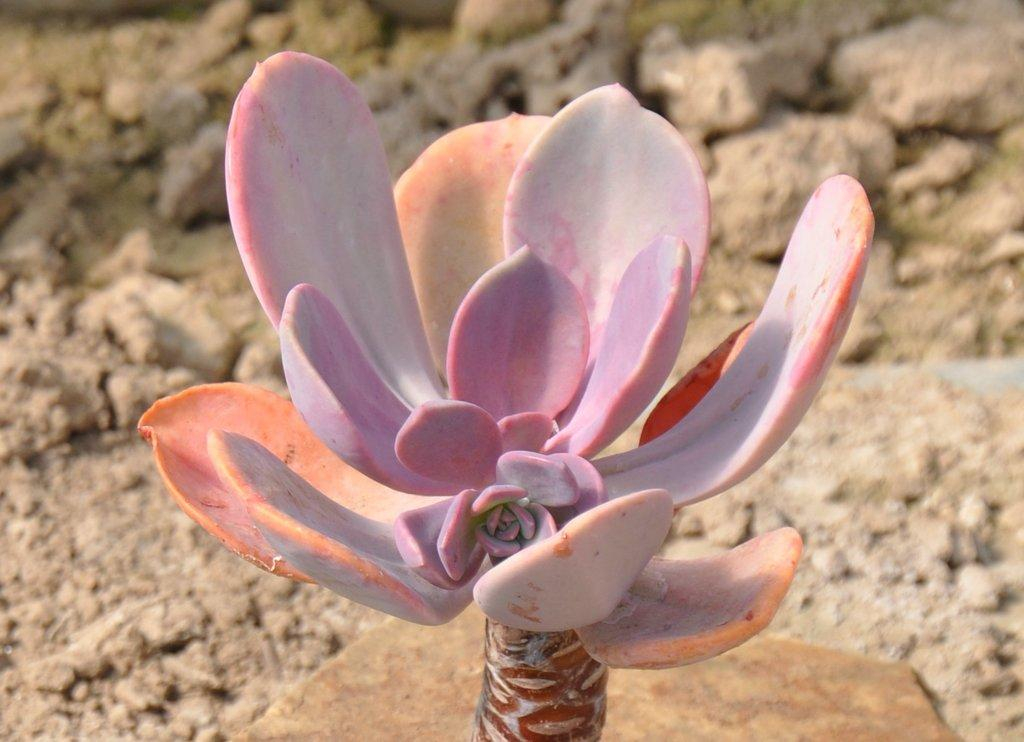What type of plant is in the image? There is a ti plant in the image. What can be seen on the ground in the image? There is soil visible on the ground in the image. What type of servant is depicted in the image? There is no servant depicted in the image; it features a ti plant and soil. What direction is the ti plant facing in the image? The provided facts do not mention the direction the ti plant is facing, so it cannot be determined from the image. 